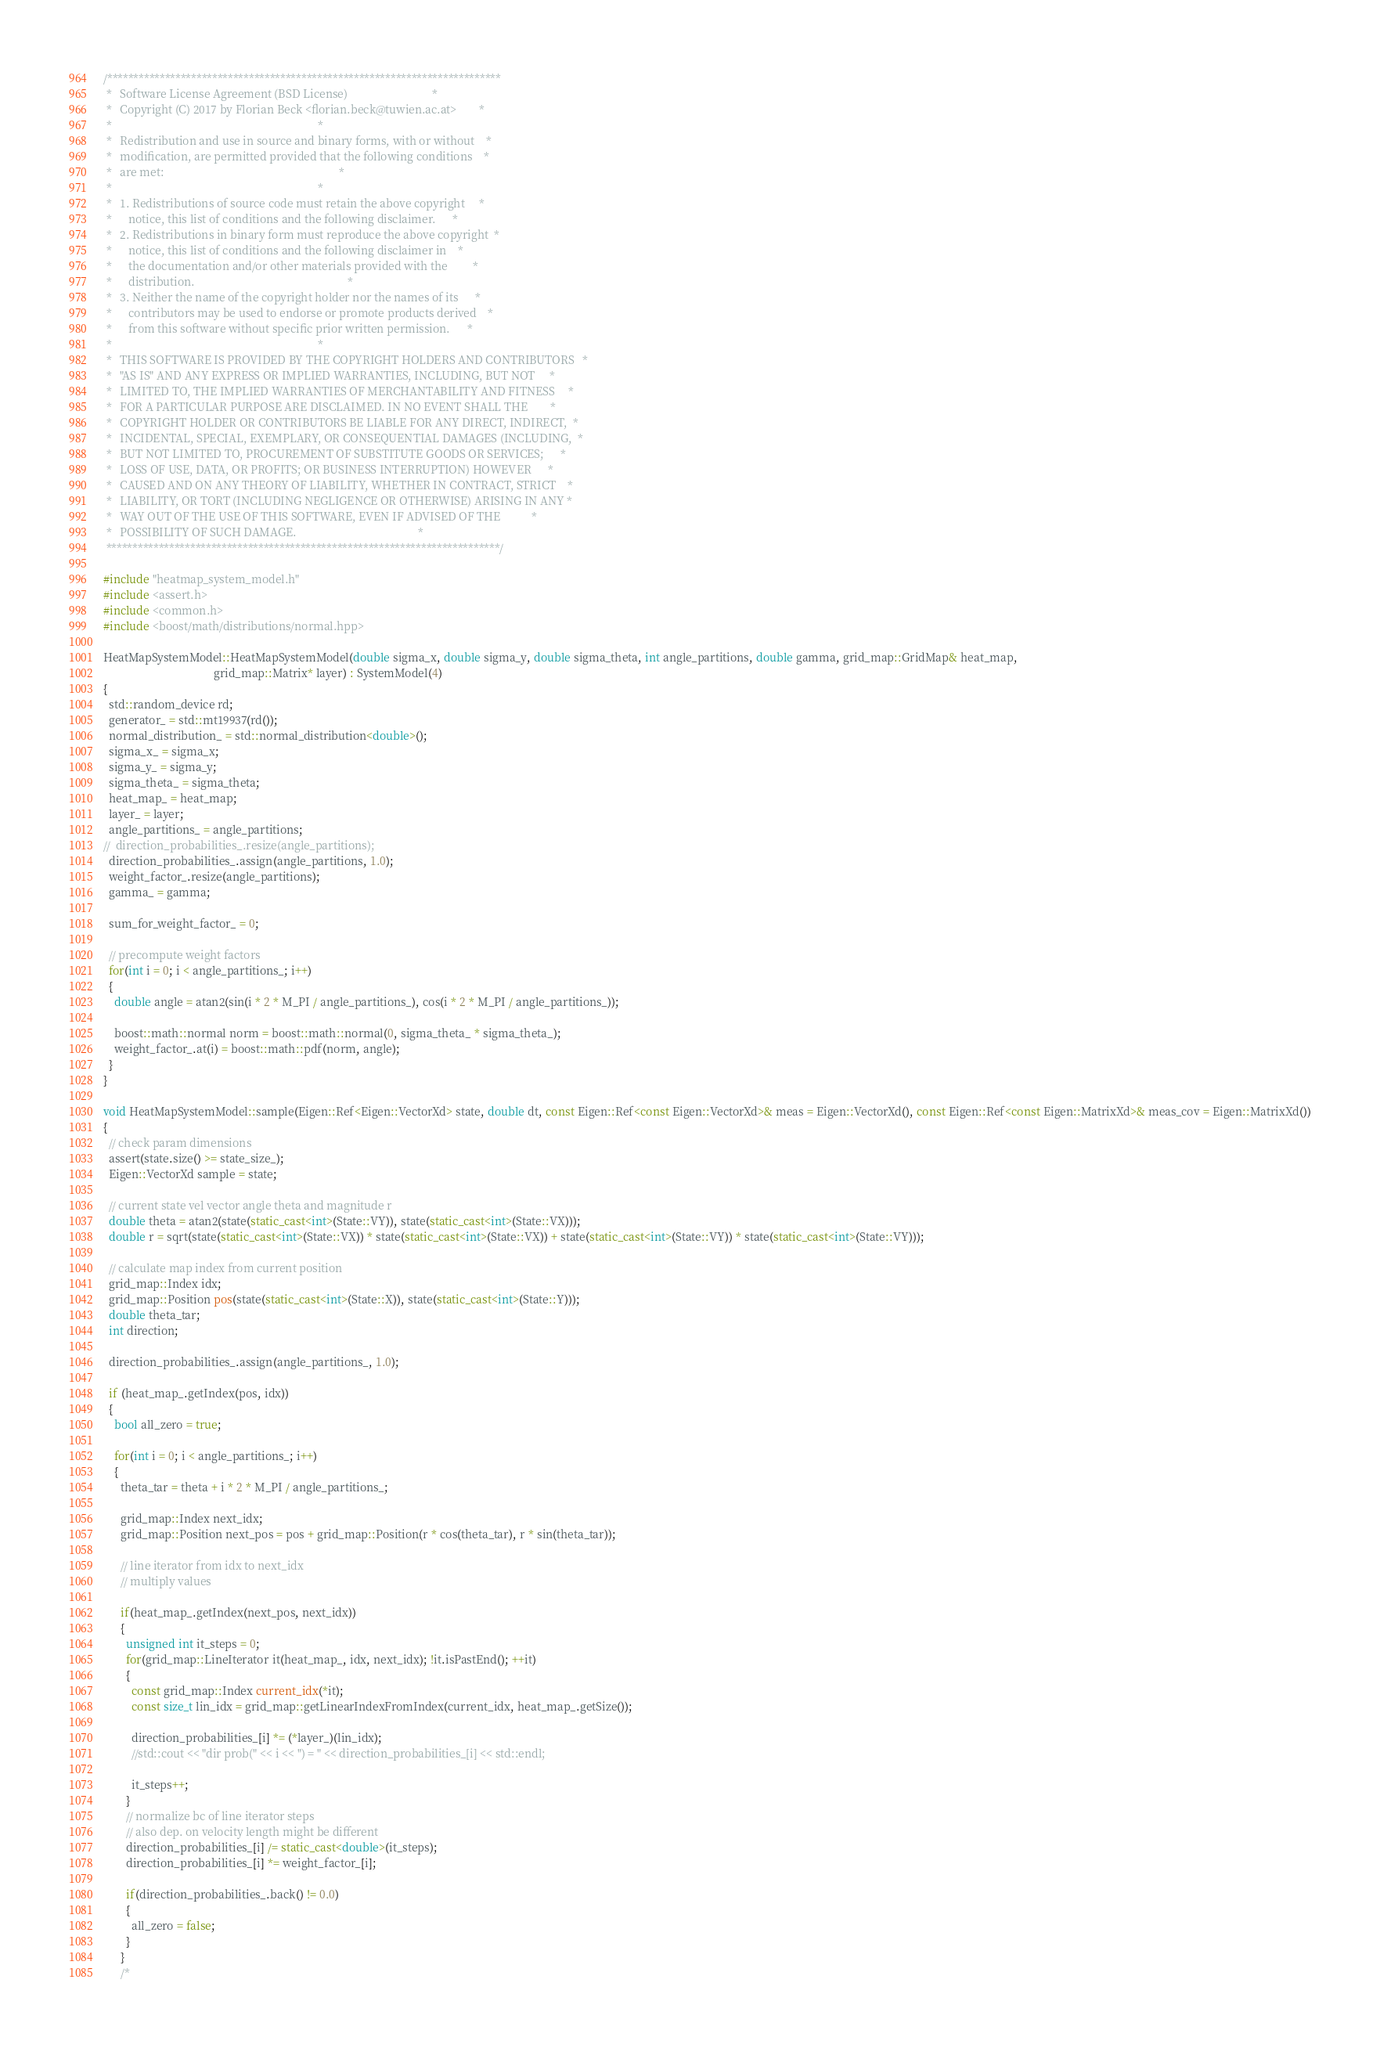Convert code to text. <code><loc_0><loc_0><loc_500><loc_500><_C++_>/***************************************************************************
 *   Software License Agreement (BSD License)                              *
 *   Copyright (C) 2017 by Florian Beck <florian.beck@tuwien.ac.at>        *
 *                                                                         *
 *   Redistribution and use in source and binary forms, with or without    *
 *   modification, are permitted provided that the following conditions    *
 *   are met:                                                              *
 *                                                                         *
 *   1. Redistributions of source code must retain the above copyright     *
 *      notice, this list of conditions and the following disclaimer.      *
 *   2. Redistributions in binary form must reproduce the above copyright  *
 *      notice, this list of conditions and the following disclaimer in    *
 *      the documentation and/or other materials provided with the         *
 *      distribution.                                                      *
 *   3. Neither the name of the copyright holder nor the names of its      *
 *      contributors may be used to endorse or promote products derived    *
 *      from this software without specific prior written permission.      *
 *                                                                         *
 *   THIS SOFTWARE IS PROVIDED BY THE COPYRIGHT HOLDERS AND CONTRIBUTORS   *
 *   "AS IS" AND ANY EXPRESS OR IMPLIED WARRANTIES, INCLUDING, BUT NOT     *
 *   LIMITED TO, THE IMPLIED WARRANTIES OF MERCHANTABILITY AND FITNESS     *
 *   FOR A PARTICULAR PURPOSE ARE DISCLAIMED. IN NO EVENT SHALL THE        *
 *   COPYRIGHT HOLDER OR CONTRIBUTORS BE LIABLE FOR ANY DIRECT, INDIRECT,  *
 *   INCIDENTAL, SPECIAL, EXEMPLARY, OR CONSEQUENTIAL DAMAGES (INCLUDING,  *
 *   BUT NOT LIMITED TO, PROCUREMENT OF SUBSTITUTE GOODS OR SERVICES;      *
 *   LOSS OF USE, DATA, OR PROFITS; OR BUSINESS INTERRUPTION) HOWEVER      *
 *   CAUSED AND ON ANY THEORY OF LIABILITY, WHETHER IN CONTRACT, STRICT    *
 *   LIABILITY, OR TORT (INCLUDING NEGLIGENCE OR OTHERWISE) ARISING IN ANY *
 *   WAY OUT OF THE USE OF THIS SOFTWARE, EVEN IF ADVISED OF THE           *
 *   POSSIBILITY OF SUCH DAMAGE.                                           *
 ***************************************************************************/

#include "heatmap_system_model.h"
#include <assert.h>
#include <common.h>
#include <boost/math/distributions/normal.hpp>

HeatMapSystemModel::HeatMapSystemModel(double sigma_x, double sigma_y, double sigma_theta, int angle_partitions, double gamma, grid_map::GridMap& heat_map,
                                       grid_map::Matrix* layer) : SystemModel(4)
{
  std::random_device rd;
  generator_ = std::mt19937(rd());
  normal_distribution_ = std::normal_distribution<double>();
  sigma_x_ = sigma_x;
  sigma_y_ = sigma_y;
  sigma_theta_ = sigma_theta;
  heat_map_ = heat_map;
  layer_ = layer;
  angle_partitions_ = angle_partitions;
//  direction_probabilities_.resize(angle_partitions);
  direction_probabilities_.assign(angle_partitions, 1.0);
  weight_factor_.resize(angle_partitions);
  gamma_ = gamma;
  
  sum_for_weight_factor_ = 0;
  
  // precompute weight factors
  for(int i = 0; i < angle_partitions_; i++)
  {    
    double angle = atan2(sin(i * 2 * M_PI / angle_partitions_), cos(i * 2 * M_PI / angle_partitions_));
    
    boost::math::normal norm = boost::math::normal(0, sigma_theta_ * sigma_theta_);
    weight_factor_.at(i) = boost::math::pdf(norm, angle);
  }
}

void HeatMapSystemModel::sample(Eigen::Ref<Eigen::VectorXd> state, double dt, const Eigen::Ref<const Eigen::VectorXd>& meas = Eigen::VectorXd(), const Eigen::Ref<const Eigen::MatrixXd>& meas_cov = Eigen::MatrixXd())
{  
  // check param dimensions
  assert(state.size() >= state_size_);
  Eigen::VectorXd sample = state;

  // current state vel vector angle theta and magnitude r
  double theta = atan2(state(static_cast<int>(State::VY)), state(static_cast<int>(State::VX)));
  double r = sqrt(state(static_cast<int>(State::VX)) * state(static_cast<int>(State::VX)) + state(static_cast<int>(State::VY)) * state(static_cast<int>(State::VY)));

  // calculate map index from current position
  grid_map::Index idx;
  grid_map::Position pos(state(static_cast<int>(State::X)), state(static_cast<int>(State::Y)));
  double theta_tar;
  int direction;
  
  direction_probabilities_.assign(angle_partitions_, 1.0);

  if (heat_map_.getIndex(pos, idx))
  {
    bool all_zero = true;
    
    for(int i = 0; i < angle_partitions_; i++)
    {
      theta_tar = theta + i * 2 * M_PI / angle_partitions_;
      
      grid_map::Index next_idx;
      grid_map::Position next_pos = pos + grid_map::Position(r * cos(theta_tar), r * sin(theta_tar));
      
      // line iterator from idx to next_idx
      // multiply values
      
      if(heat_map_.getIndex(next_pos, next_idx))
      {
        unsigned int it_steps = 0;
        for(grid_map::LineIterator it(heat_map_, idx, next_idx); !it.isPastEnd(); ++it)
        {
          const grid_map::Index current_idx(*it);
          const size_t lin_idx = grid_map::getLinearIndexFromIndex(current_idx, heat_map_.getSize());
          
          direction_probabilities_[i] *= (*layer_)(lin_idx);
          //std::cout << "dir prob(" << i << ") = " << direction_probabilities_[i] << std::endl;
          
          it_steps++;
        }
        // normalize bc of line iterator steps
        // also dep. on velocity length might be different
        direction_probabilities_[i] /= static_cast<double>(it_steps); 
        direction_probabilities_[i] *= weight_factor_[i];
        
        if(direction_probabilities_.back() != 0.0)
        {
          all_zero = false;
        }
      }
      /*</code> 